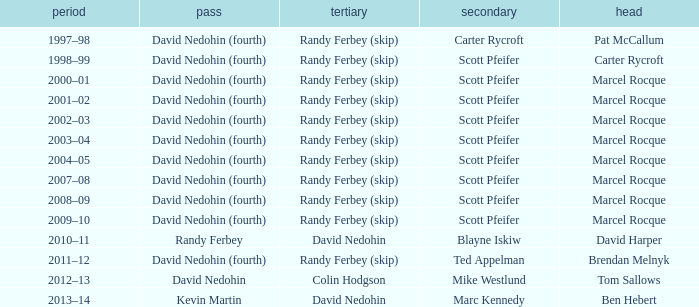Which Lead has a Third of randy ferbey (skip), a Second of scott pfeifer, and a Season of 2009–10? Marcel Rocque. 